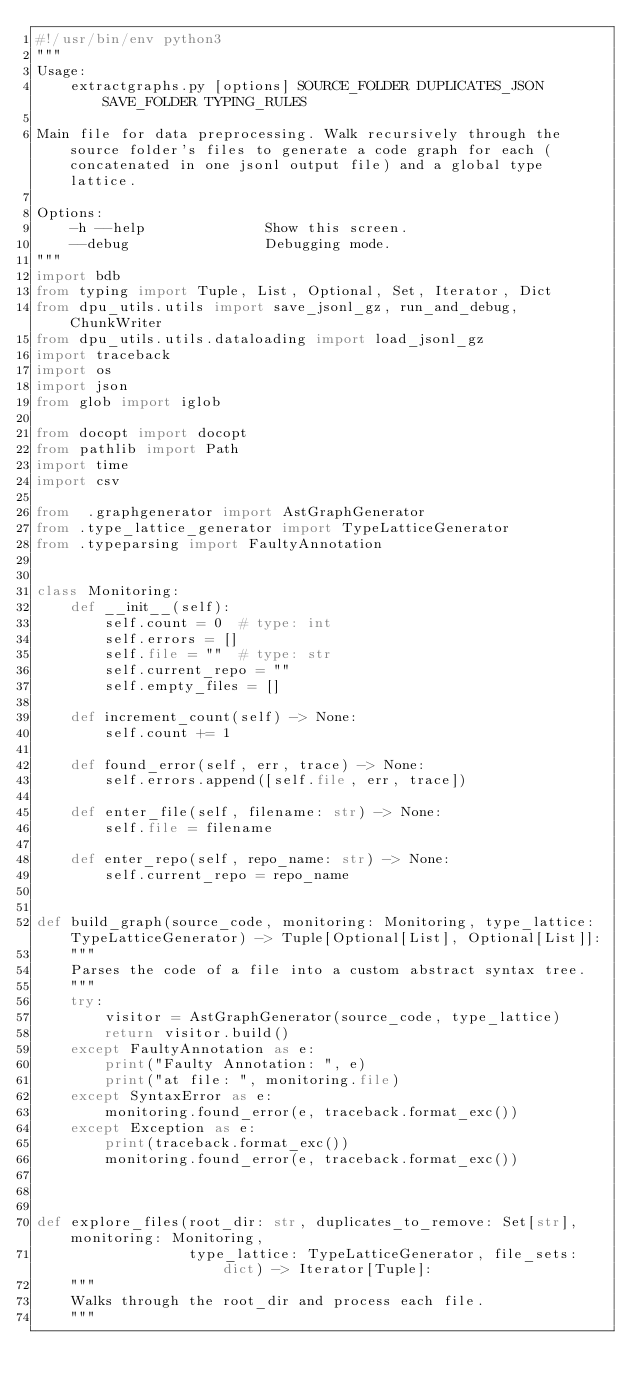Convert code to text. <code><loc_0><loc_0><loc_500><loc_500><_Python_>#!/usr/bin/env python3
"""
Usage:
    extractgraphs.py [options] SOURCE_FOLDER DUPLICATES_JSON SAVE_FOLDER TYPING_RULES

Main file for data preprocessing. Walk recursively through the source folder's files to generate a code graph for each (concatenated in one jsonl output file) and a global type lattice.

Options:
    -h --help              Show this screen.
    --debug                Debugging mode.
"""
import bdb
from typing import Tuple, List, Optional, Set, Iterator, Dict
from dpu_utils.utils import save_jsonl_gz, run_and_debug, ChunkWriter
from dpu_utils.utils.dataloading import load_jsonl_gz
import traceback
import os
import json
from glob import iglob

from docopt import docopt
from pathlib import Path
import time
import csv

from  .graphgenerator import AstGraphGenerator
from .type_lattice_generator import TypeLatticeGenerator
from .typeparsing import FaultyAnnotation


class Monitoring:
    def __init__(self):
        self.count = 0  # type: int
        self.errors = []
        self.file = ""  # type: str
        self.current_repo = ""
        self.empty_files = []

    def increment_count(self) -> None:
        self.count += 1

    def found_error(self, err, trace) -> None:
        self.errors.append([self.file, err, trace])

    def enter_file(self, filename: str) -> None:
        self.file = filename

    def enter_repo(self, repo_name: str) -> None:
        self.current_repo = repo_name


def build_graph(source_code, monitoring: Monitoring, type_lattice: TypeLatticeGenerator) -> Tuple[Optional[List], Optional[List]]:
    """
    Parses the code of a file into a custom abstract syntax tree.
    """
    try:
        visitor = AstGraphGenerator(source_code, type_lattice)
        return visitor.build()
    except FaultyAnnotation as e:
        print("Faulty Annotation: ", e)
        print("at file: ", monitoring.file)
    except SyntaxError as e:
        monitoring.found_error(e, traceback.format_exc())
    except Exception as e:
        print(traceback.format_exc())
        monitoring.found_error(e, traceback.format_exc())



def explore_files(root_dir: str, duplicates_to_remove: Set[str], monitoring: Monitoring,
                  type_lattice: TypeLatticeGenerator, file_sets: dict) -> Iterator[Tuple]:
    """
    Walks through the root_dir and process each file.
    """</code> 